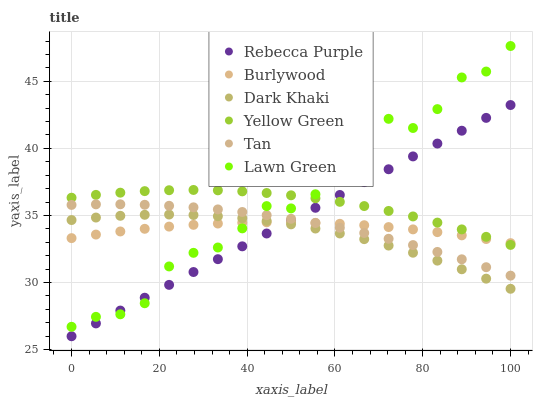Does Dark Khaki have the minimum area under the curve?
Answer yes or no. Yes. Does Lawn Green have the maximum area under the curve?
Answer yes or no. Yes. Does Yellow Green have the minimum area under the curve?
Answer yes or no. No. Does Yellow Green have the maximum area under the curve?
Answer yes or no. No. Is Rebecca Purple the smoothest?
Answer yes or no. Yes. Is Lawn Green the roughest?
Answer yes or no. Yes. Is Yellow Green the smoothest?
Answer yes or no. No. Is Yellow Green the roughest?
Answer yes or no. No. Does Rebecca Purple have the lowest value?
Answer yes or no. Yes. Does Yellow Green have the lowest value?
Answer yes or no. No. Does Lawn Green have the highest value?
Answer yes or no. Yes. Does Yellow Green have the highest value?
Answer yes or no. No. Is Dark Khaki less than Tan?
Answer yes or no. Yes. Is Tan greater than Dark Khaki?
Answer yes or no. Yes. Does Yellow Green intersect Burlywood?
Answer yes or no. Yes. Is Yellow Green less than Burlywood?
Answer yes or no. No. Is Yellow Green greater than Burlywood?
Answer yes or no. No. Does Dark Khaki intersect Tan?
Answer yes or no. No. 